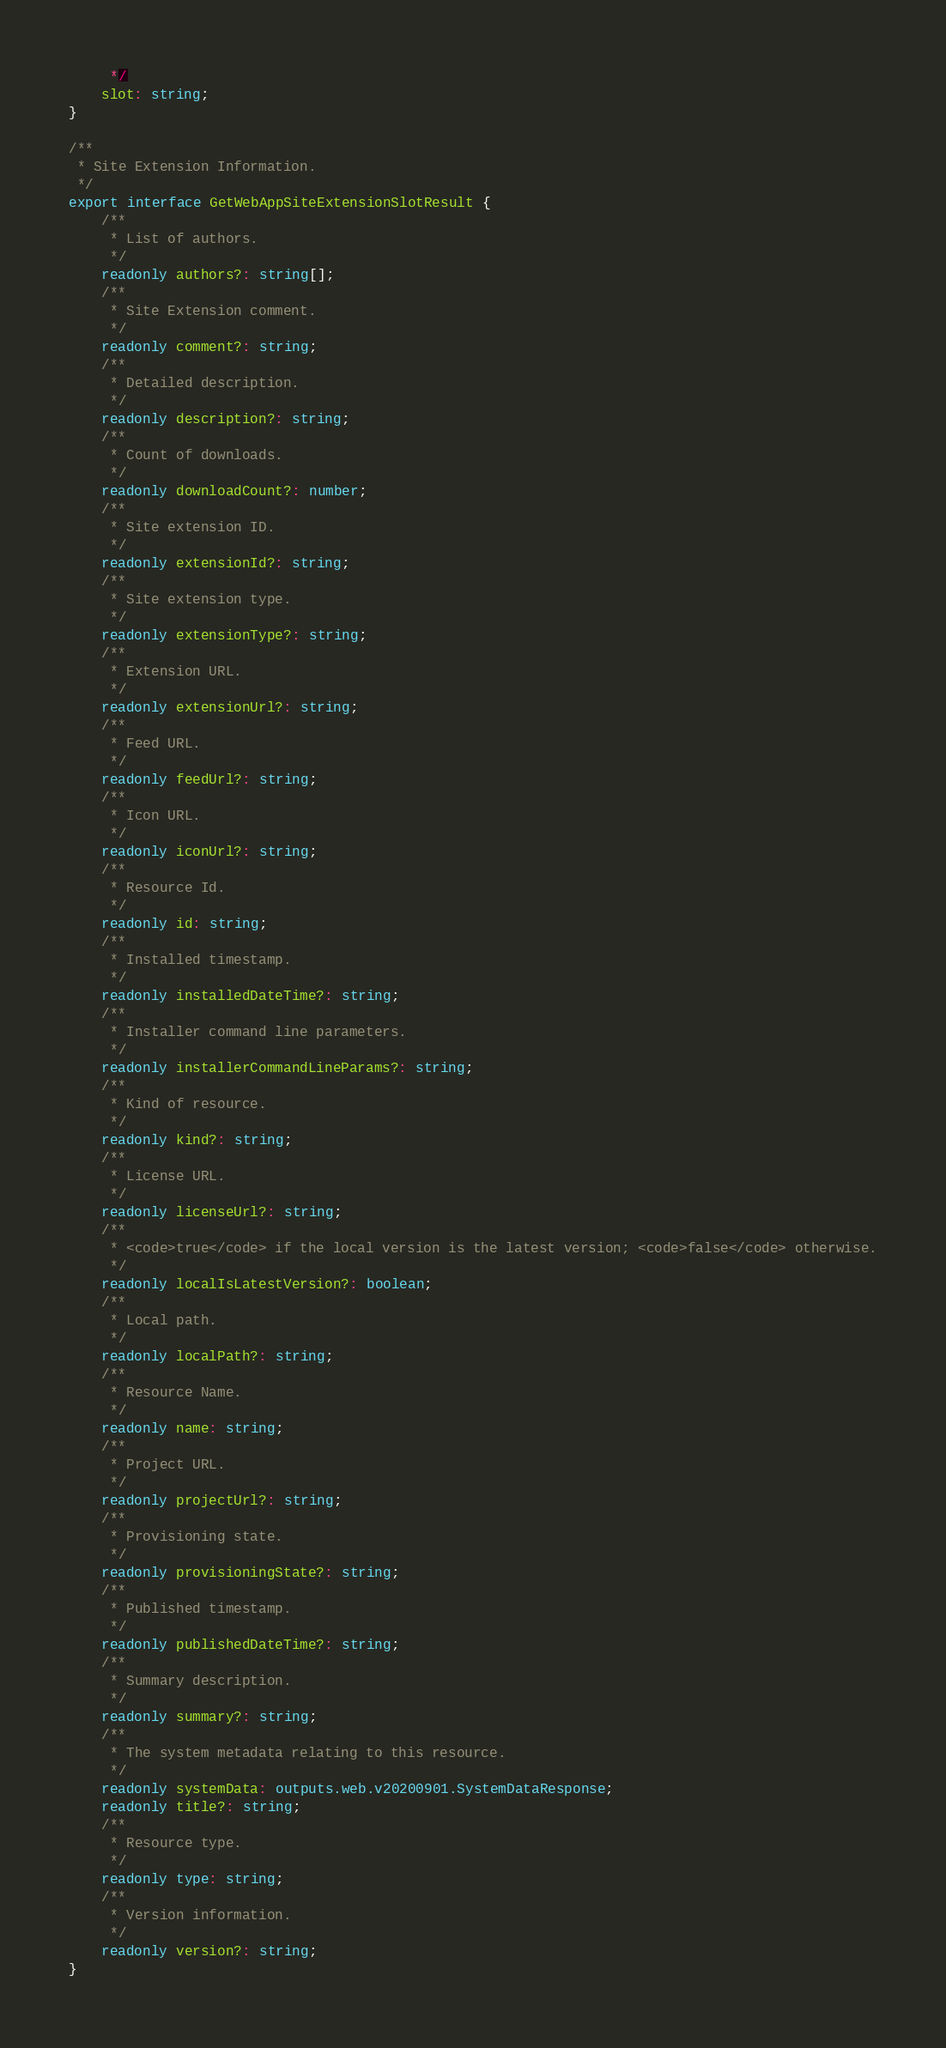Convert code to text. <code><loc_0><loc_0><loc_500><loc_500><_TypeScript_>     */
    slot: string;
}

/**
 * Site Extension Information.
 */
export interface GetWebAppSiteExtensionSlotResult {
    /**
     * List of authors.
     */
    readonly authors?: string[];
    /**
     * Site Extension comment.
     */
    readonly comment?: string;
    /**
     * Detailed description.
     */
    readonly description?: string;
    /**
     * Count of downloads.
     */
    readonly downloadCount?: number;
    /**
     * Site extension ID.
     */
    readonly extensionId?: string;
    /**
     * Site extension type.
     */
    readonly extensionType?: string;
    /**
     * Extension URL.
     */
    readonly extensionUrl?: string;
    /**
     * Feed URL.
     */
    readonly feedUrl?: string;
    /**
     * Icon URL.
     */
    readonly iconUrl?: string;
    /**
     * Resource Id.
     */
    readonly id: string;
    /**
     * Installed timestamp.
     */
    readonly installedDateTime?: string;
    /**
     * Installer command line parameters.
     */
    readonly installerCommandLineParams?: string;
    /**
     * Kind of resource.
     */
    readonly kind?: string;
    /**
     * License URL.
     */
    readonly licenseUrl?: string;
    /**
     * <code>true</code> if the local version is the latest version; <code>false</code> otherwise.
     */
    readonly localIsLatestVersion?: boolean;
    /**
     * Local path.
     */
    readonly localPath?: string;
    /**
     * Resource Name.
     */
    readonly name: string;
    /**
     * Project URL.
     */
    readonly projectUrl?: string;
    /**
     * Provisioning state.
     */
    readonly provisioningState?: string;
    /**
     * Published timestamp.
     */
    readonly publishedDateTime?: string;
    /**
     * Summary description.
     */
    readonly summary?: string;
    /**
     * The system metadata relating to this resource.
     */
    readonly systemData: outputs.web.v20200901.SystemDataResponse;
    readonly title?: string;
    /**
     * Resource type.
     */
    readonly type: string;
    /**
     * Version information.
     */
    readonly version?: string;
}
</code> 